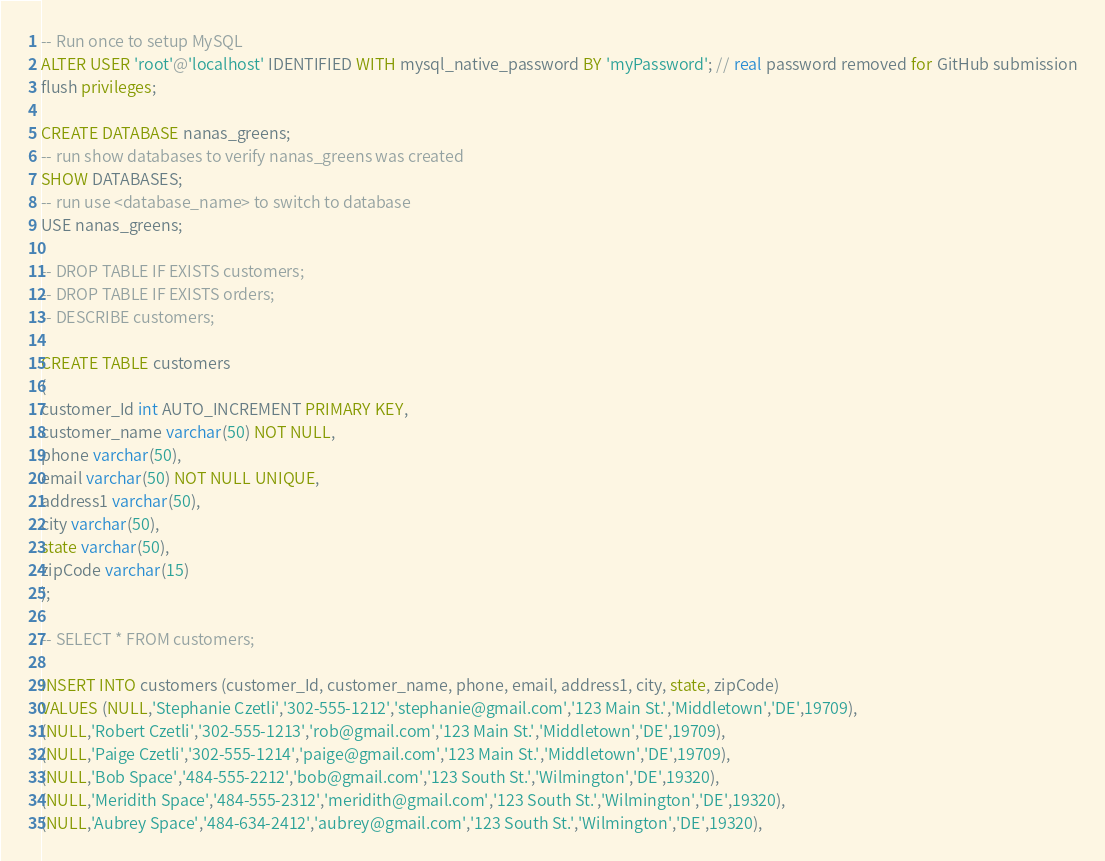Convert code to text. <code><loc_0><loc_0><loc_500><loc_500><_SQL_>-- Run once to setup MySQL
ALTER USER 'root'@'localhost' IDENTIFIED WITH mysql_native_password BY 'myPassword'; // real password removed for GitHub submission
flush privileges;

CREATE DATABASE nanas_greens;
-- run show databases to verify nanas_greens was created
SHOW DATABASES;
-- run use <database_name> to switch to database
USE nanas_greens;

-- DROP TABLE IF EXISTS customers;
-- DROP TABLE IF EXISTS orders;
-- DESCRIBE customers;

CREATE TABLE customers
(
customer_Id int AUTO_INCREMENT PRIMARY KEY,
customer_name varchar(50) NOT NULL, 
phone varchar(50),
email varchar(50) NOT NULL UNIQUE,
address1 varchar(50),
city varchar(50),
state varchar(50),
zipCode varchar(15)
);

-- SELECT * FROM customers;

INSERT INTO customers (customer_Id, customer_name, phone, email, address1, city, state, zipCode)
VALUES (NULL,'Stephanie Czetli','302-555-1212','stephanie@gmail.com','123 Main St.','Middletown','DE',19709),
(NULL,'Robert Czetli','302-555-1213','rob@gmail.com','123 Main St.','Middletown','DE',19709),
(NULL,'Paige Czetli','302-555-1214','paige@gmail.com','123 Main St.','Middletown','DE',19709),
(NULL,'Bob Space','484-555-2212','bob@gmail.com','123 South St.','Wilmington','DE',19320),
(NULL,'Meridith Space','484-555-2312','meridith@gmail.com','123 South St.','Wilmington','DE',19320),
(NULL,'Aubrey Space','484-634-2412','aubrey@gmail.com','123 South St.','Wilmington','DE',19320),</code> 